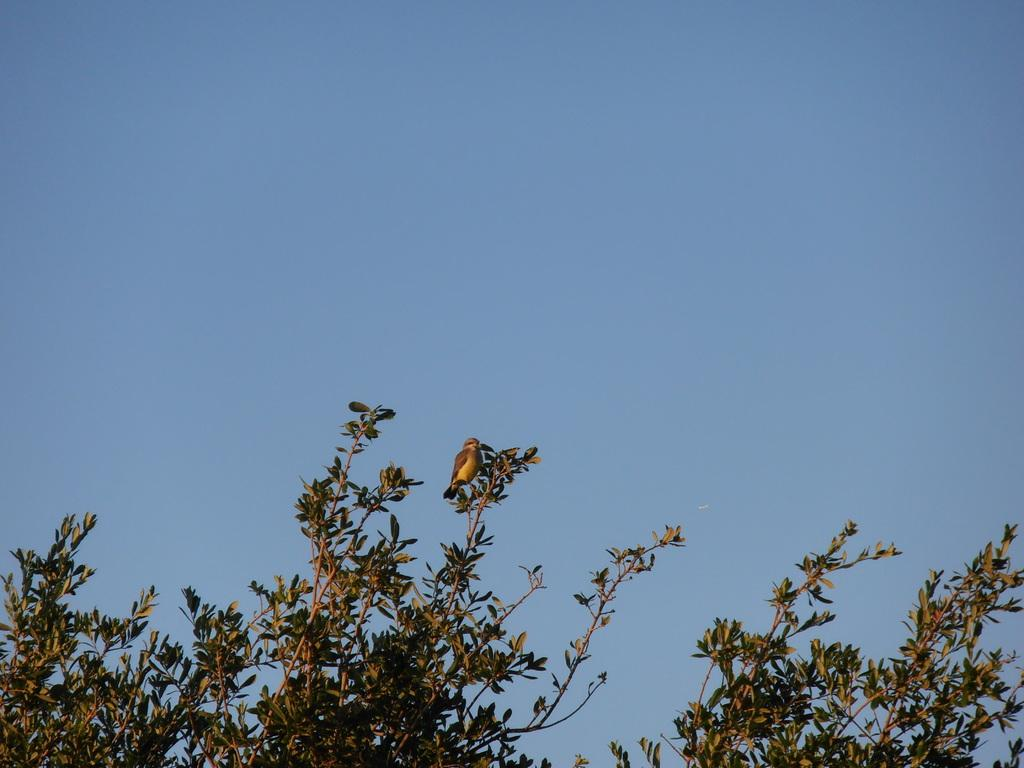What can be seen in the background of the image? The sky is visible in the background of the image. What type of vegetation is present in the image? There is a tree in the image. What type of animal is present in the image? There is a bird in the image. What type of crow is offering a suggestion in the image? There is no crow present in the image, nor is there any suggestion being offered. 